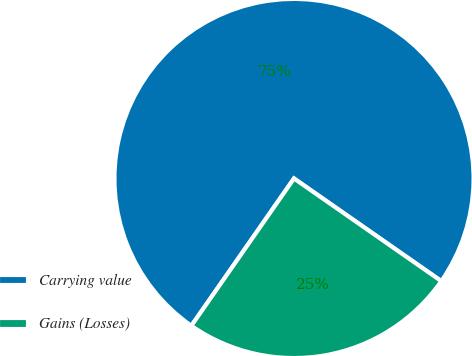Convert chart. <chart><loc_0><loc_0><loc_500><loc_500><pie_chart><fcel>Carrying value<fcel>Gains (Losses)<nl><fcel>75.0%<fcel>25.0%<nl></chart> 